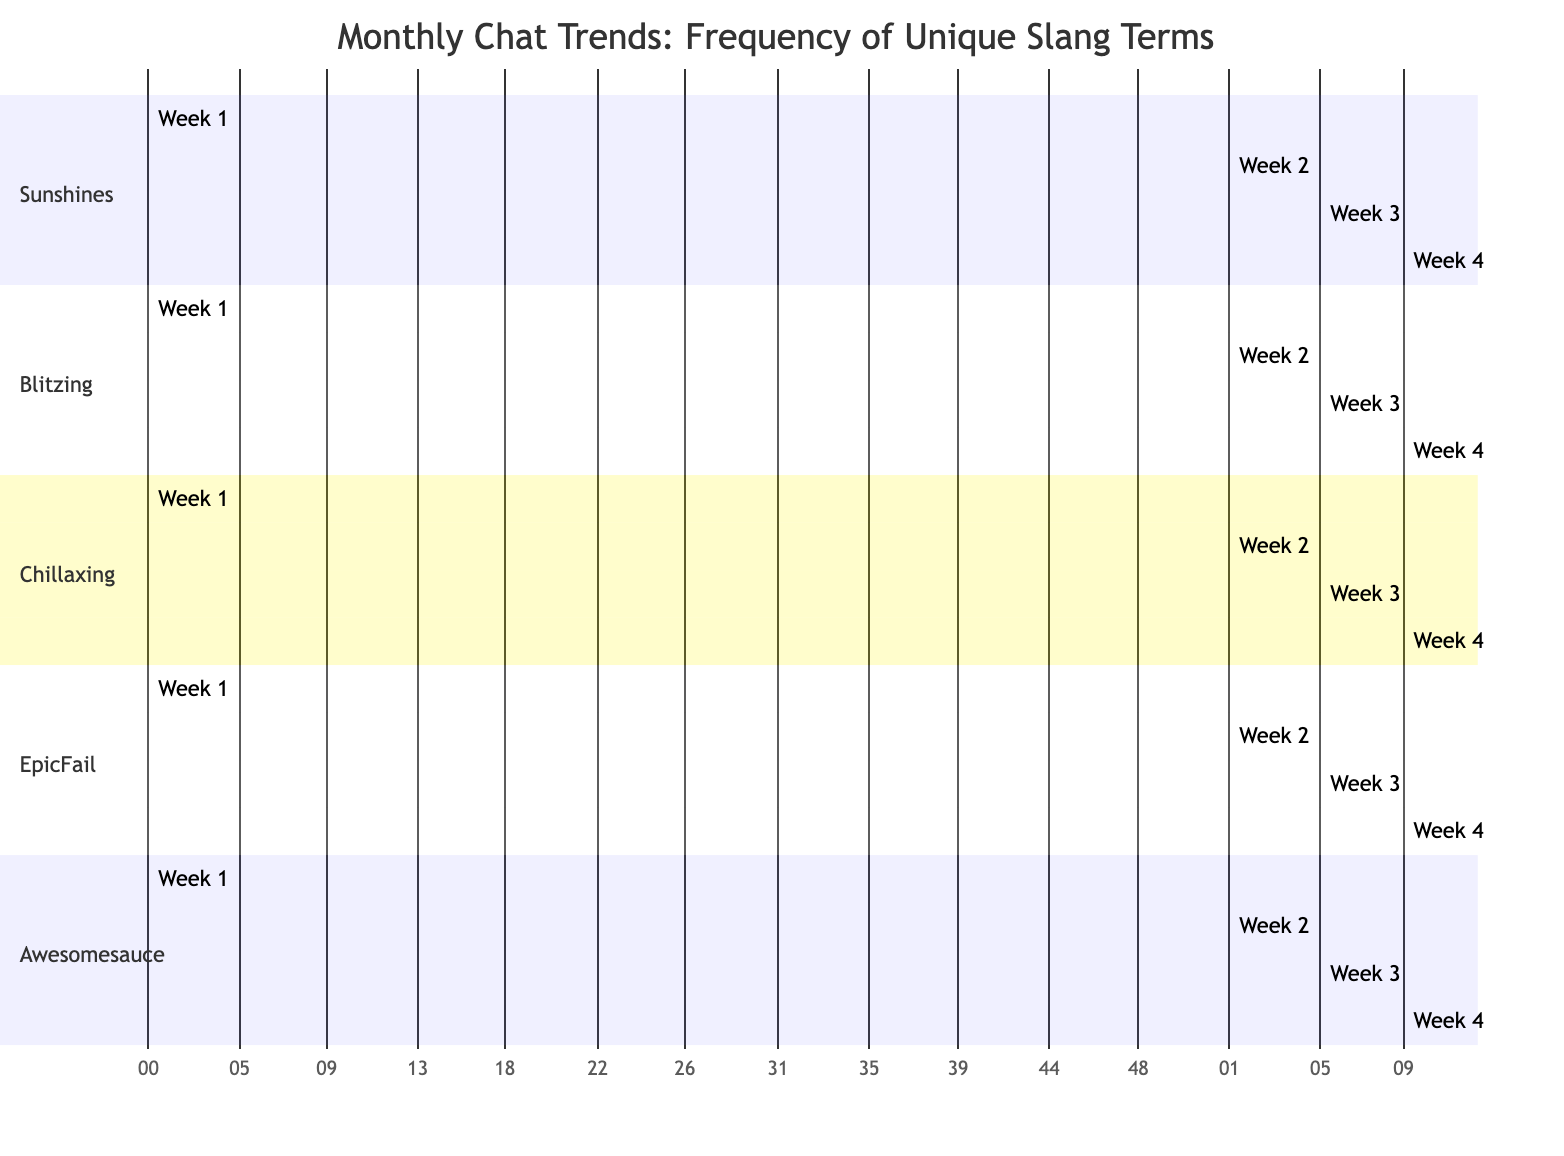How many unique slang terms are displayed in the diagram? The diagram consists of five sections, each representing a unique slang term: Sunshines, Blitzing, Chillaxing, EpicFail, and Awesomesauce. Thus, the total number of unique slang terms is five.
Answer: 5 Which week had the highest use of the slang term "EpicFail"? Looking at the data under the "EpicFail" section, Week 3 shows a frequency of 22, which is higher than the values in other weeks. Thus, Week 3 had the highest use of the slang term "EpicFail".
Answer: Week 3 What was the frequency of "Chillaxing" in Week 2? Under the section for "Chillaxing", the value for Week 2 is 18. Therefore, the frequency of "Chillaxing" in Week 2 is 18.
Answer: 18 Which slang term had the lowest frequency in Week 1? Comparing the values for Week 1 across all slang terms, "Awesomesauce" has the lowest frequency at 5. Therefore, "Awesomesauce" is the slang term with the lowest frequency in Week 1.
Answer: Awesomesauce What is the total frequency of "Blitzing" over all weeks? To find the total frequency for "Blitzing", we sum the values for each week: 8 (Week 1) + 12 (Week 2) + 14 (Week 3) + 16 (Week 4) which equals 50. Therefore, the total frequency of "Blitzing" over all weeks is 50.
Answer: 50 In which week did "Sunshines" see a drop in usage compared to the previous week? By reviewing the data under "Sunshines", we see that Week 3 has a frequency of 10, which is a drop from Week 2's 20. Hence, "Sunshines" saw a drop in usage during Week 3 compared to Week 2.
Answer: Week 3 What was the usage trend of "Awesomesauce" throughout the month? Observing the values for "Awesomesauce" across the weeks: 5 (Week 1), 7 (Week 2), 9 (Week 3), and 6 (Week 4), we note an increase in the first three weeks, followed by a decrease in Week 4. Thus, the trend shows an initial rise followed by a decline.
Answer: Rise and fall Which slang term showed the most consistent usage across all weeks? By examining the frequencies for each slang term across the weeks, "Blitzing" has values of 8, 12, 14, and 16. The changes are not too drastic, making its usage more consistent compared to the others. Therefore, "Blitzing" showed the most consistent usage across all weeks.
Answer: Blitzing 